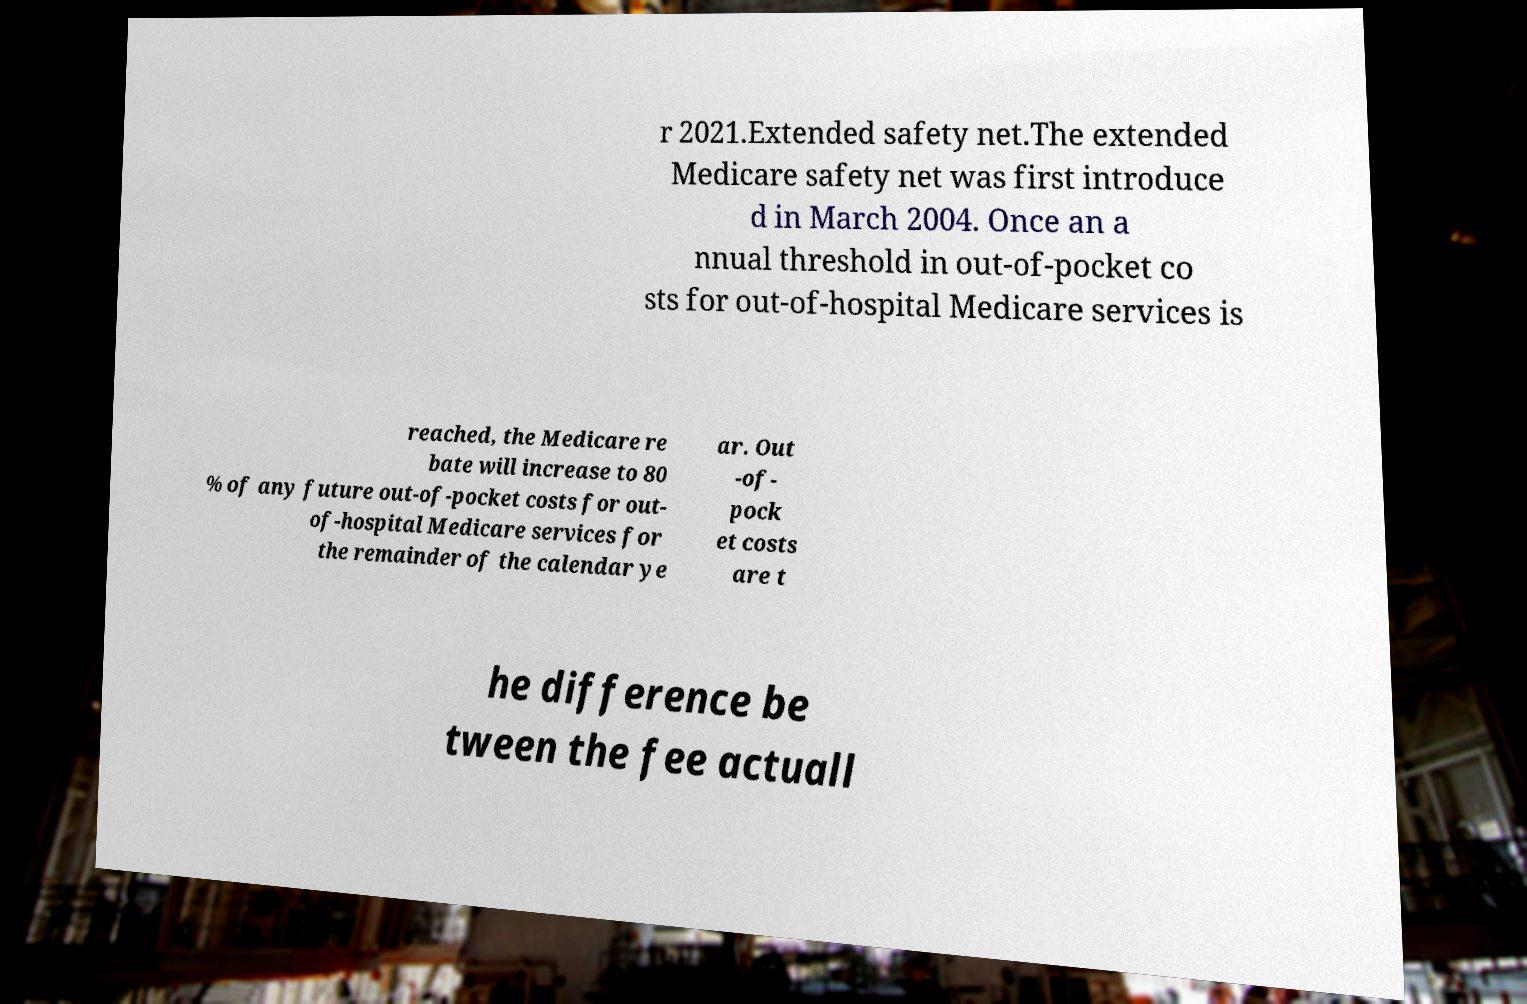Could you extract and type out the text from this image? r 2021.Extended safety net.The extended Medicare safety net was first introduce d in March 2004. Once an a nnual threshold in out-of-pocket co sts for out-of-hospital Medicare services is reached, the Medicare re bate will increase to 80 % of any future out-of-pocket costs for out- of-hospital Medicare services for the remainder of the calendar ye ar. Out -of- pock et costs are t he difference be tween the fee actuall 